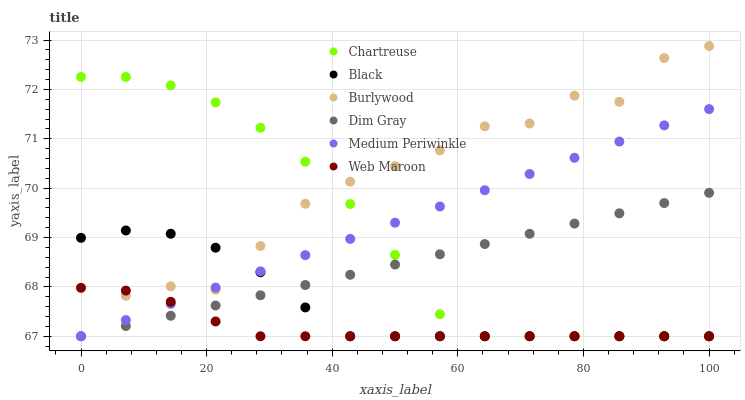Does Web Maroon have the minimum area under the curve?
Answer yes or no. Yes. Does Burlywood have the maximum area under the curve?
Answer yes or no. Yes. Does Burlywood have the minimum area under the curve?
Answer yes or no. No. Does Web Maroon have the maximum area under the curve?
Answer yes or no. No. Is Dim Gray the smoothest?
Answer yes or no. Yes. Is Burlywood the roughest?
Answer yes or no. Yes. Is Web Maroon the smoothest?
Answer yes or no. No. Is Web Maroon the roughest?
Answer yes or no. No. Does Dim Gray have the lowest value?
Answer yes or no. Yes. Does Burlywood have the highest value?
Answer yes or no. Yes. Does Web Maroon have the highest value?
Answer yes or no. No. Does Web Maroon intersect Burlywood?
Answer yes or no. Yes. Is Web Maroon less than Burlywood?
Answer yes or no. No. Is Web Maroon greater than Burlywood?
Answer yes or no. No. 